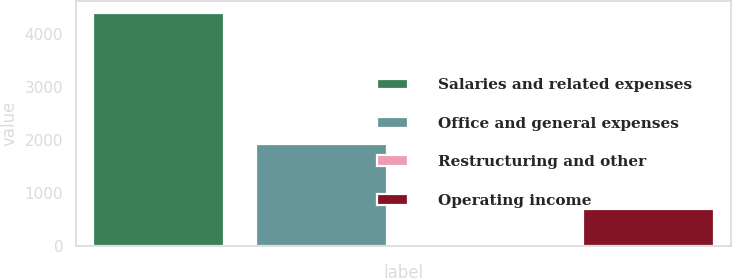<chart> <loc_0><loc_0><loc_500><loc_500><bar_chart><fcel>Salaries and related expenses<fcel>Office and general expenses<fcel>Restructuring and other<fcel>Operating income<nl><fcel>4402.1<fcel>1924.3<fcel>1<fcel>687.2<nl></chart> 